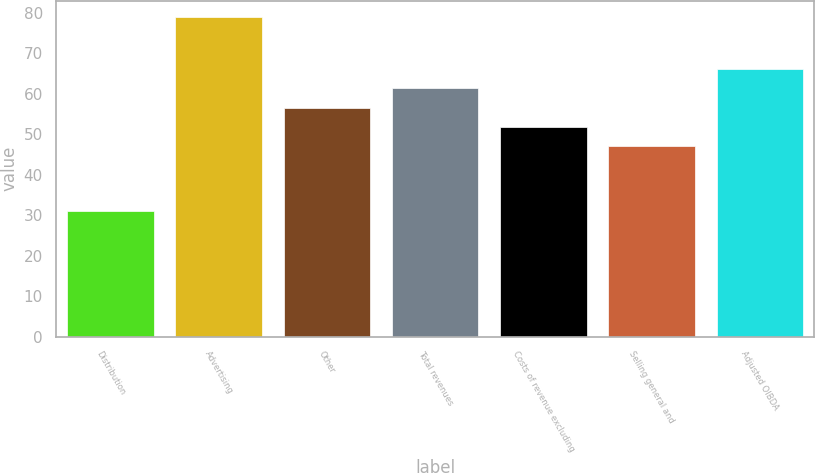Convert chart to OTSL. <chart><loc_0><loc_0><loc_500><loc_500><bar_chart><fcel>Distribution<fcel>Advertising<fcel>Other<fcel>Total revenues<fcel>Costs of revenue excluding<fcel>Selling general and<fcel>Adjusted OIBDA<nl><fcel>31<fcel>79<fcel>56.6<fcel>61.4<fcel>51.8<fcel>47<fcel>66.2<nl></chart> 